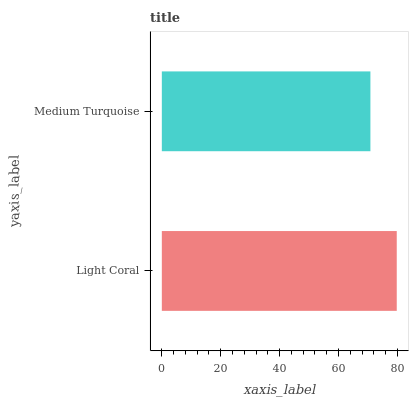Is Medium Turquoise the minimum?
Answer yes or no. Yes. Is Light Coral the maximum?
Answer yes or no. Yes. Is Medium Turquoise the maximum?
Answer yes or no. No. Is Light Coral greater than Medium Turquoise?
Answer yes or no. Yes. Is Medium Turquoise less than Light Coral?
Answer yes or no. Yes. Is Medium Turquoise greater than Light Coral?
Answer yes or no. No. Is Light Coral less than Medium Turquoise?
Answer yes or no. No. Is Light Coral the high median?
Answer yes or no. Yes. Is Medium Turquoise the low median?
Answer yes or no. Yes. Is Medium Turquoise the high median?
Answer yes or no. No. Is Light Coral the low median?
Answer yes or no. No. 